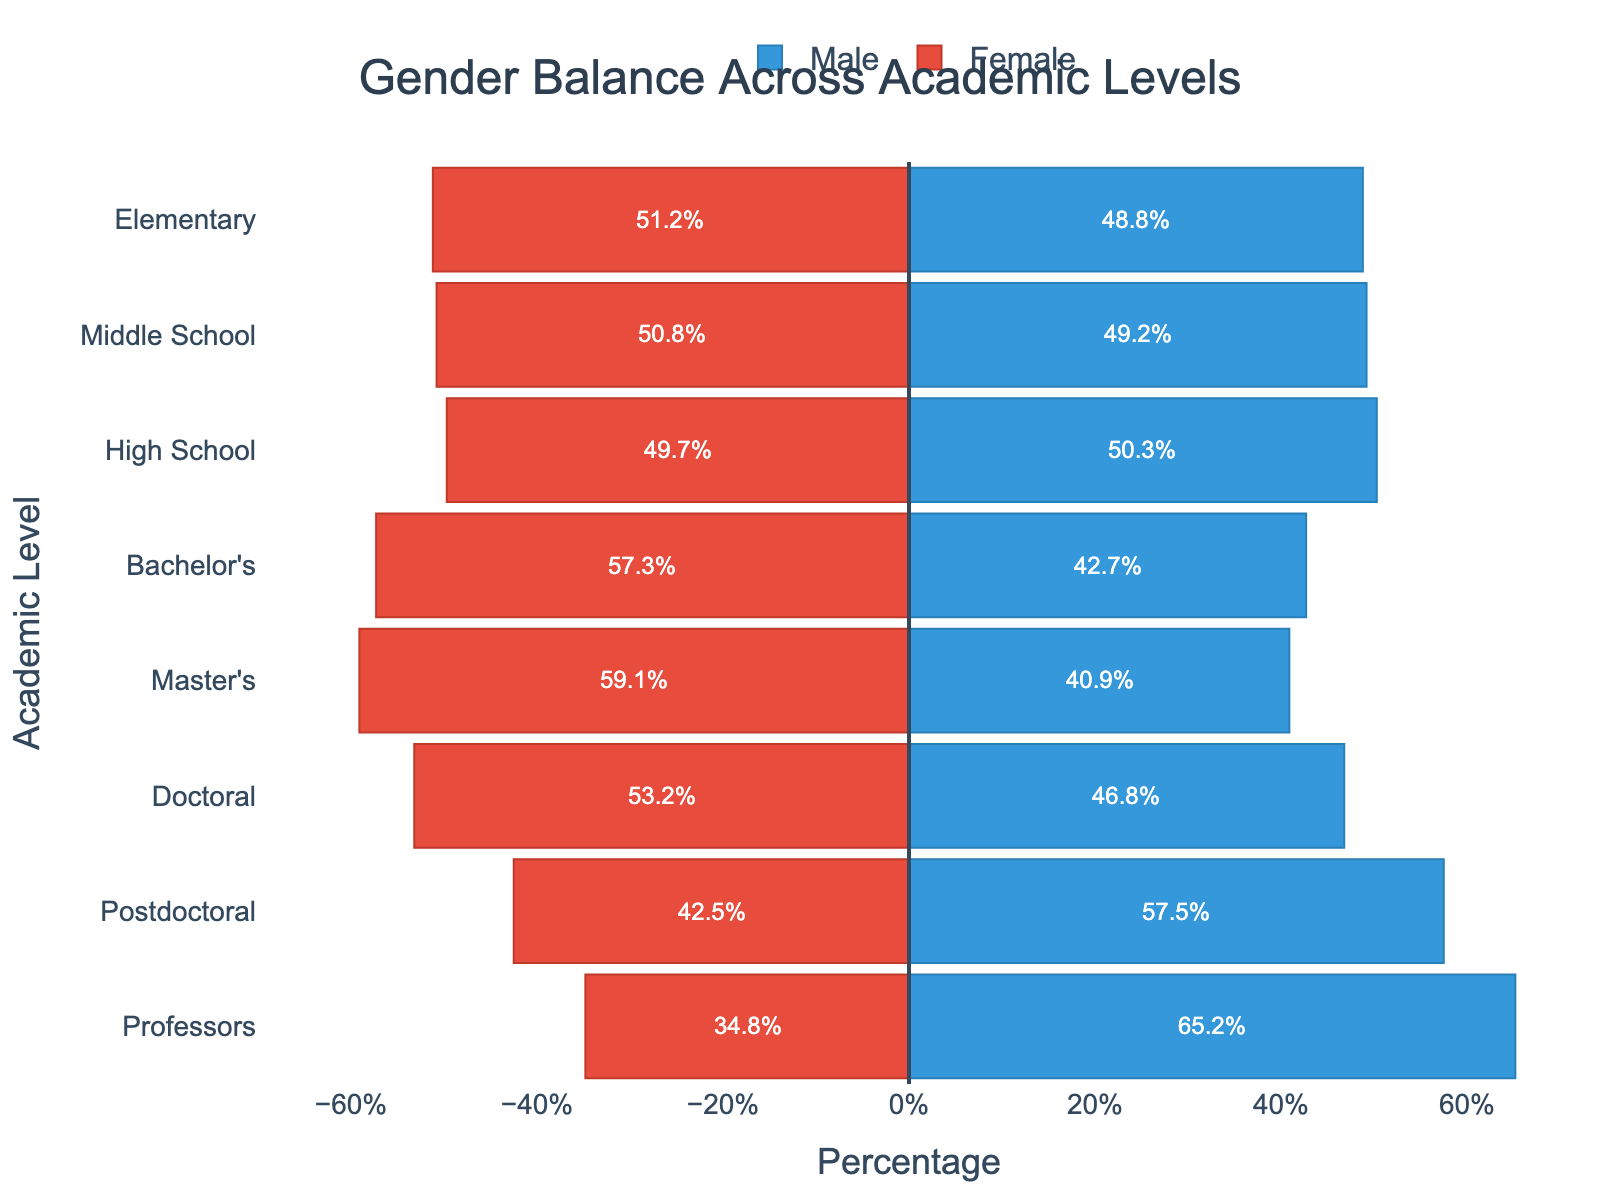What is the title of the figure? The title is displayed at the top center of the plot. It reads "Gender Balance Across Academic Levels".
Answer: Gender Balance Across Academic Levels Which academic level has the highest percentage of female participants? Looking at the plot, the widest red bar on the left side (negative values) corresponds to the Bachelor's level, with females making up 57.3%.
Answer: Bachelor's What is the approximate difference in percentage between male and female participants at the Doctoral level? The female percentage at the Doctoral level is 53.2%, and the male percentage is 46.8%. The difference is calculated as 53.2% - 46.8% = 6.4%.
Answer: 6.4% Which two academic levels show an almost equal gender distribution? Looking at the plot, Elementary and Middle School levels have nearly equal bars for both male and female percentages. Elementary is 51.2% female, 48.8% male; Middle School is 50.8% female, 49.2% male.
Answer: Elementary and Middle School How does the gender balance change from Bachelor's to Master's level? The Bachelor's level has 57.3% female and 42.7% male; moving to the Master's level, the female percentage increases to 59.1% while the male percentage decreases to 40.9%. The change is an increase of 1.8% for females and a decrease of 1.8% for males.
Answer: Female percentage increases, male percentage decreases Compare the gender distribution between Postdoctoral and Professors levels. At the Postdoctoral level, 57.5% are male and 42.5% are female. At the Professors level, 65.2% are male and 34.8% are female. Therefore, there are more males and fewer females as we move from Postdoctoral to Professors.
Answer: More males and fewer females at the Professors level compared to Postdoctoral What is the trend in female representation from Elementary to Professors? The female representation initially declines slightly from Elementary to High School, then increases significantly at Bachelor's and Master's levels, decreases again at the Doctoral level, and continues to decrease through Postdoctoral and Professors levels.
Answer: Initially decreases, increases at Bachelor's and Master's, and then decreases again from Doctoral onwards What is the combined percentage of male and female participants at the High School level? The percentage of male participants is 50.3% and the percentage of female participants is 49.7%. Adding them gives 50.3 + 49.7 = 100%.
Answer: 100% Which academic level has the largest gender gap, and what is the magnitude of this gap? The Professors level has the largest gender gap. The male percentage is 65.2% and the female percentage is 34.8%. The gap is 65.2% - 34.8% = 30.4%.
Answer: Professors, 30.4% 